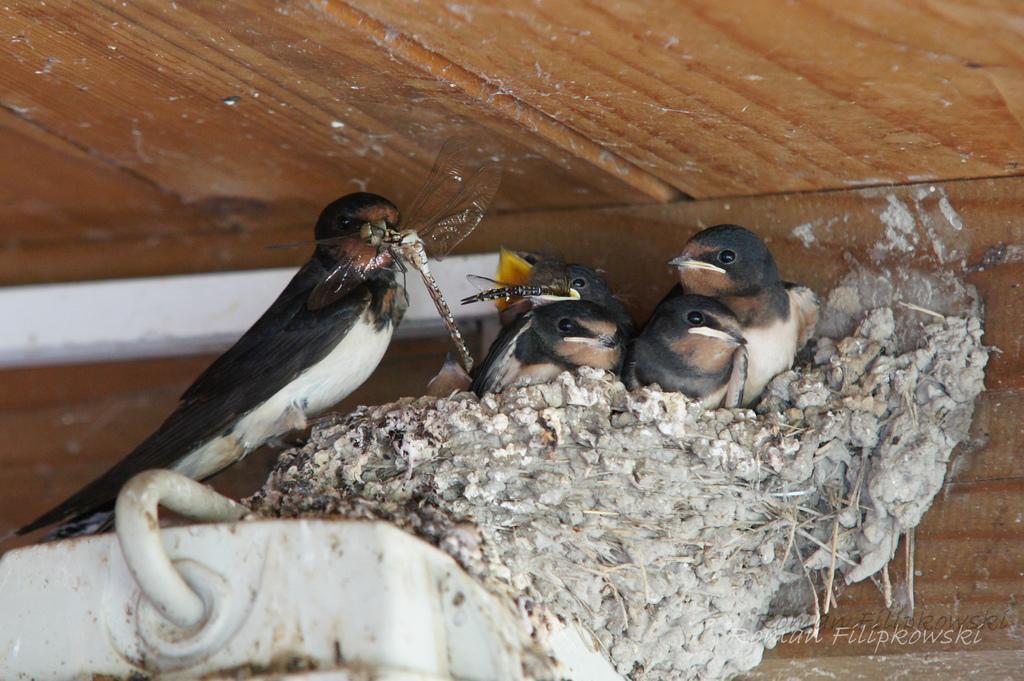Could you give a brief overview of what you see in this image? Here I can see few birds on a nest. Two birds are holding dragonflies in its mouth. On the left side there is a metal object. At the top of the image there is a wooden surface. In the bottom right-hand corner there is some text. 